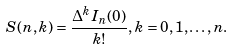Convert formula to latex. <formula><loc_0><loc_0><loc_500><loc_500>S ( n , k ) = \frac { \Delta ^ { k } I _ { n } ( 0 ) } { k ! } , k = 0 , 1 , \dots , n .</formula> 